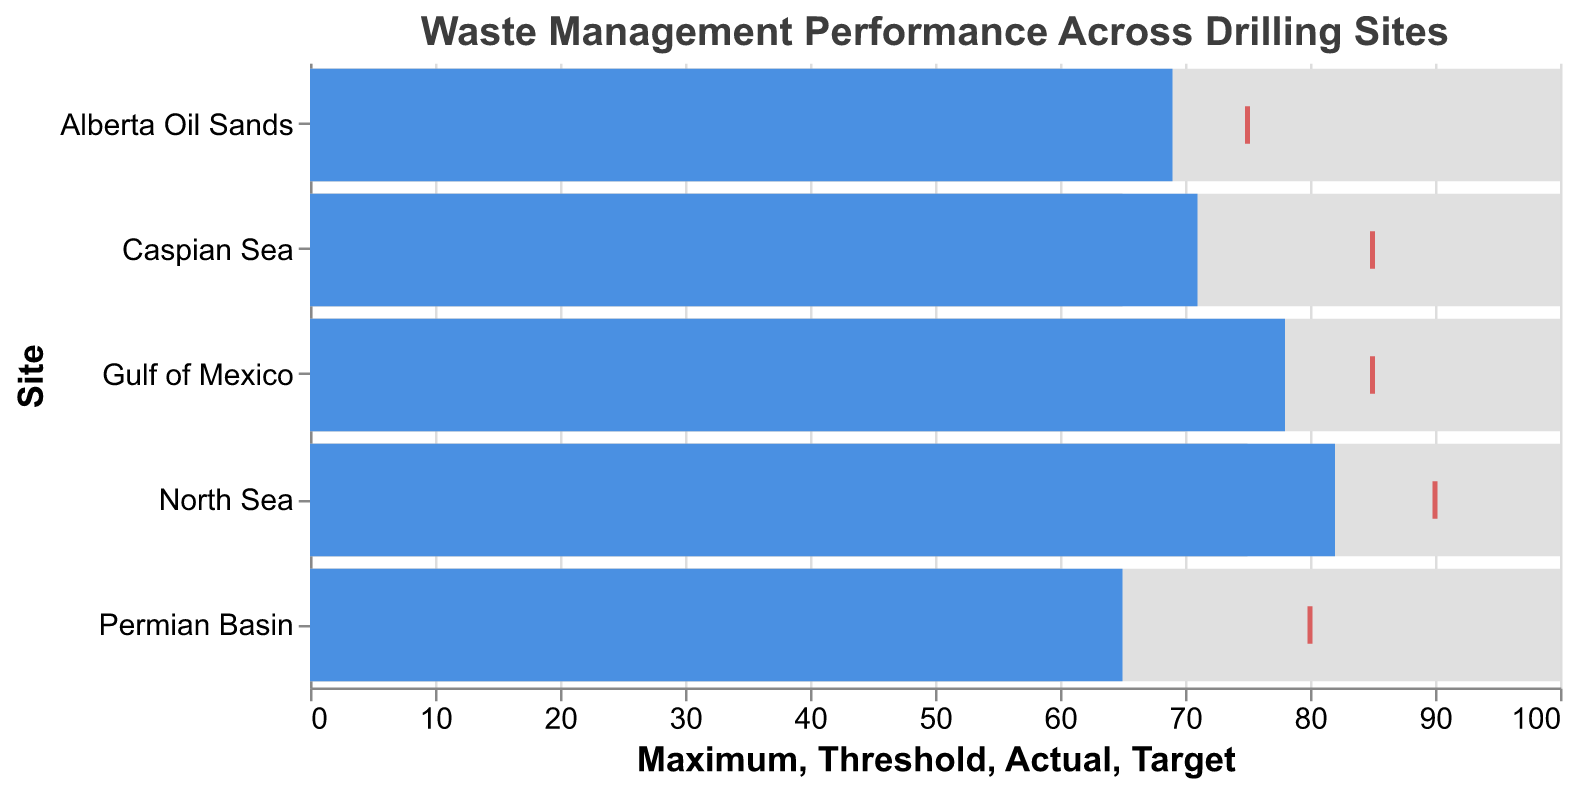What is the title of the chart? The title of the chart is located at the top and reads "Waste Management Performance Across Drilling Sites." This indicates the subject and objective of the data visualization.
Answer: Waste Management Performance Across Drilling Sites What are the five drilling sites displayed in the chart? The drilling sites are labeled on the y-axis. From the chart, the sites listed are Gulf of Mexico, North Sea, Permian Basin, Caspian Sea, and Alberta Oil Sands.
Answer: Gulf of Mexico, North Sea, Permian Basin, Caspian Sea, Alberta Oil Sands Which site has the lowest actual waste management performance? By comparing the blue bars that represent actual performance, the Permian Basin has the lowest actual value, labeled as 65.
Answer: Permian Basin Is the actual performance of the North Sea above or below its target? The red tick mark represents the target value, and the blue bar represents the actual value. For the North Sea, the blue bar (82) is below the red tick mark (90).
Answer: Below How much higher is the target value than the actual value for the Gulf of Mexico? The target value is marked by the red tick (85) and the actual value is represented by the blue bar (78). The difference is calculated as 85 - 78 = 7.
Answer: 7 Which site is closest to meeting its target? To determine this, look at the proximity of the blue bar to the red tick mark across all sites. Alberta Oil Sands has the smallest gap, with an actual value of 69 and a target of 75, resulting in a difference of 6.
Answer: Alberta Oil Sands Compare the threshold values for all sites. Are they consistent or variable? The gray bars represent threshold values, and they can be compared directly. Gulf of Mexico and North Sea have thresholds of 70 and 75 respectively, Permian Basin has 60, Caspian Sea has 65, and Alberta Oil Sands has 60, indicating they vary across sites.
Answer: Variable What is the average actual performance across all sites? Sum of the actual values: 78 (Gulf of Mexico) + 82 (North Sea) + 65 (Permian Basin) + 71 (Caspian Sea) + 69 (Alberta Oil Sands) = 365. The number of sites is 5, so the average is 365 / 5 = 73.
Answer: 73 Which site has the largest difference between its maximum and actual performance? Subtract the actual value from the maximum for each site. The differences are:
Gulf of Mexico: 100 - 78 = 22,
North Sea: 100 - 82 = 18,
Permian Basin: 100 - 65 = 35,
Caspian Sea: 100 - 71 = 29,
Alberta Oil Sands: 100 - 69 = 31.
The Permian Basin has the largest difference.
Answer: Permian Basin 